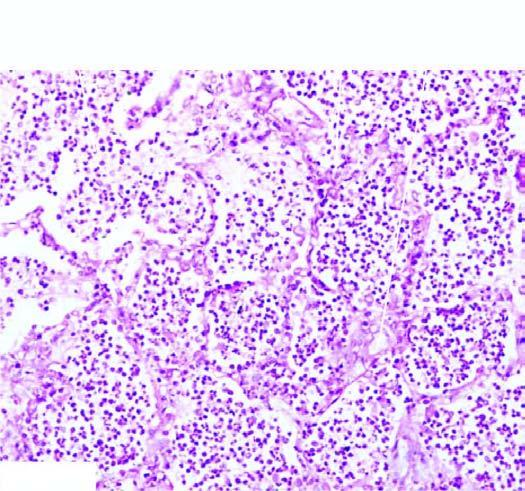re the alveoli filled with cellular exudates composed of neutrophils admixed with some red cells?
Answer the question using a single word or phrase. Yes 